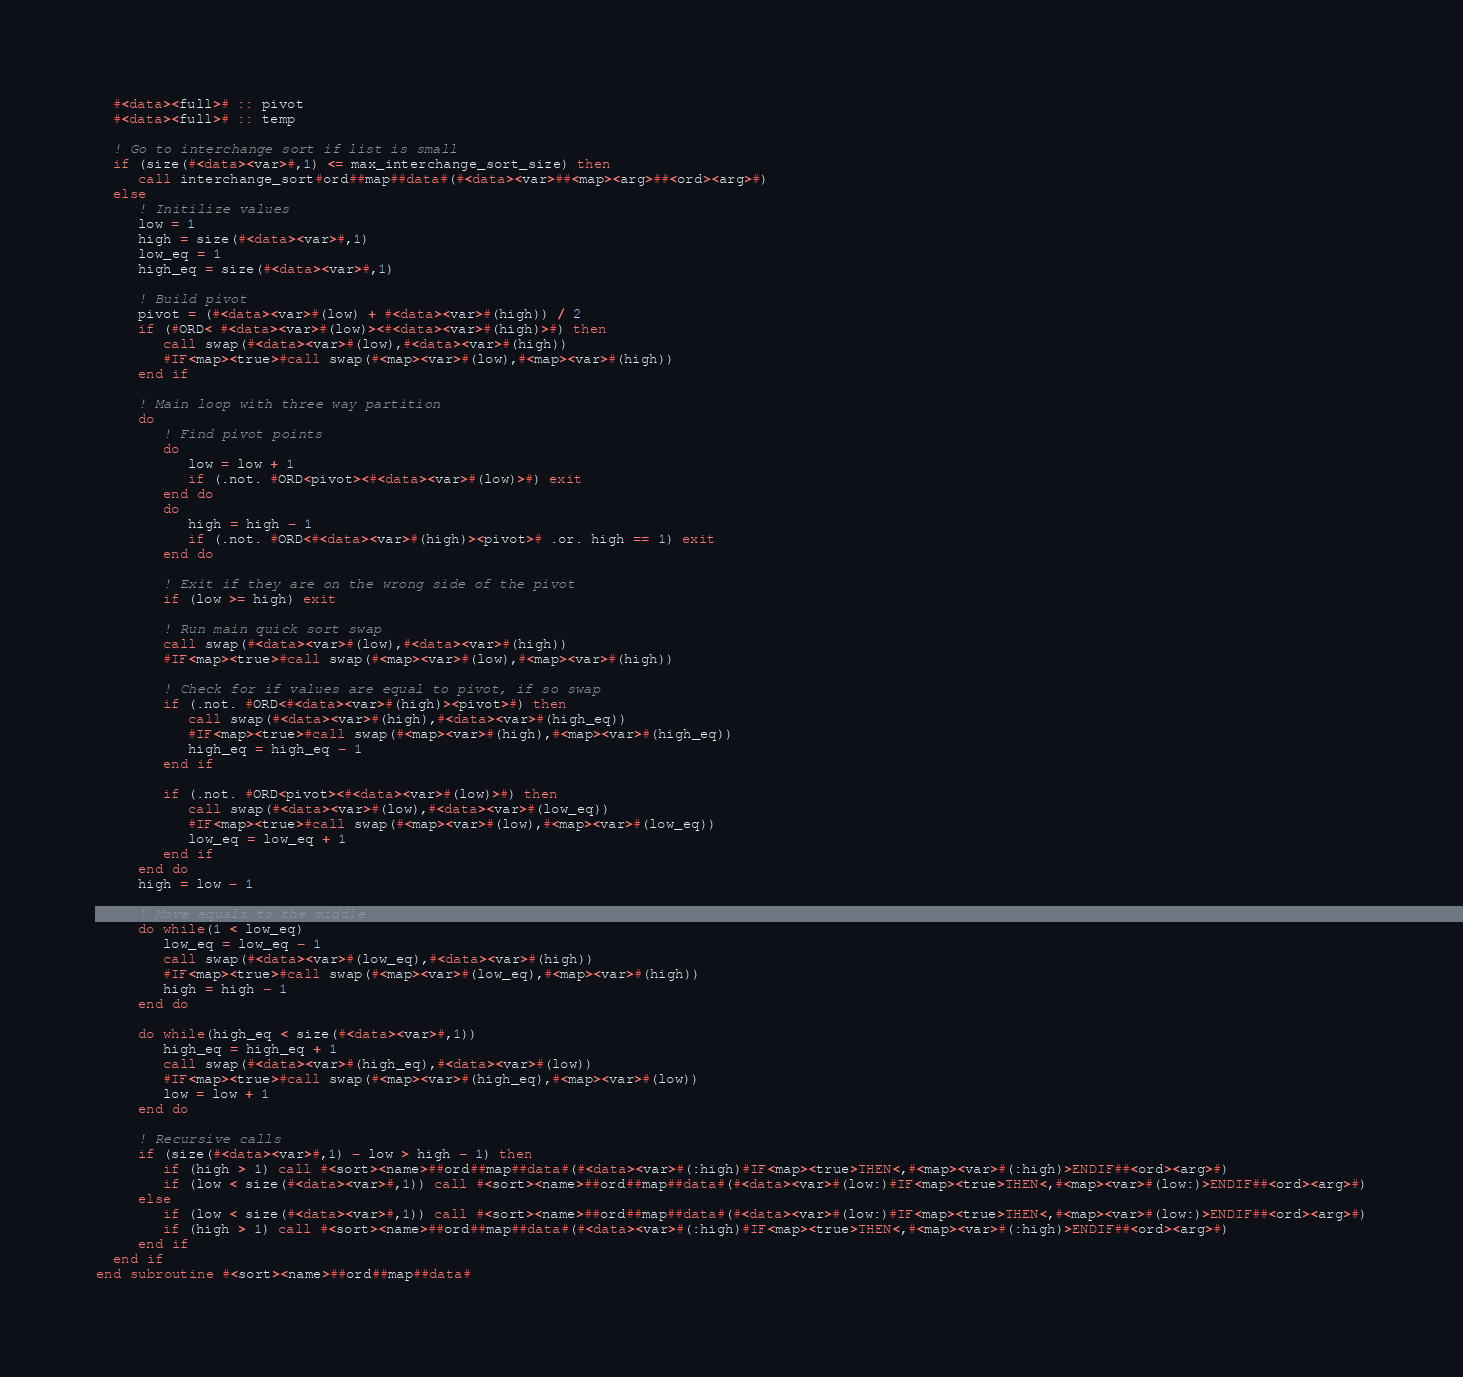Convert code to text. <code><loc_0><loc_0><loc_500><loc_500><_FORTRAN_>  #<data><full># :: pivot
  #<data><full># :: temp

  ! Go to interchange sort if list is small
  if (size(#<data><var>#,1) <= max_interchange_sort_size) then
     call interchange_sort#ord##map##data#(#<data><var>##<map><arg>##<ord><arg>#)
  else
     ! Initilize values
     low = 1
     high = size(#<data><var>#,1)
     low_eq = 1
     high_eq = size(#<data><var>#,1)

     ! Build pivot
     pivot = (#<data><var>#(low) + #<data><var>#(high)) / 2
     if (#ORD< #<data><var>#(low)><#<data><var>#(high)>#) then
        call swap(#<data><var>#(low),#<data><var>#(high))
        #IF<map><true>#call swap(#<map><var>#(low),#<map><var>#(high))
     end if
     
     ! Main loop with three way partition
     do 
        ! Find pivot points
        do
           low = low + 1
           if (.not. #ORD<pivot><#<data><var>#(low)>#) exit
        end do
        do 
           high = high - 1
           if (.not. #ORD<#<data><var>#(high)><pivot># .or. high == 1) exit
        end do

        ! Exit if they are on the wrong side of the pivot
        if (low >= high) exit

        ! Run main quick sort swap
        call swap(#<data><var>#(low),#<data><var>#(high))
        #IF<map><true>#call swap(#<map><var>#(low),#<map><var>#(high))

        ! Check for if values are equal to pivot, if so swap
        if (.not. #ORD<#<data><var>#(high)><pivot>#) then
           call swap(#<data><var>#(high),#<data><var>#(high_eq))
           #IF<map><true>#call swap(#<map><var>#(high),#<map><var>#(high_eq))
           high_eq = high_eq - 1
        end if

        if (.not. #ORD<pivot><#<data><var>#(low)>#) then
           call swap(#<data><var>#(low),#<data><var>#(low_eq))
           #IF<map><true>#call swap(#<map><var>#(low),#<map><var>#(low_eq))
           low_eq = low_eq + 1
        end if
     end do
     high = low - 1

     ! Move equals to the middle
     do while(1 < low_eq)
        low_eq = low_eq - 1
        call swap(#<data><var>#(low_eq),#<data><var>#(high))
        #IF<map><true>#call swap(#<map><var>#(low_eq),#<map><var>#(high))
        high = high - 1
     end do
     
     do while(high_eq < size(#<data><var>#,1))
        high_eq = high_eq + 1
        call swap(#<data><var>#(high_eq),#<data><var>#(low))
        #IF<map><true>#call swap(#<map><var>#(high_eq),#<map><var>#(low))
        low = low + 1
     end do
     
     ! Recursive calls 
     if (size(#<data><var>#,1) - low > high - 1) then
        if (high > 1) call #<sort><name>##ord##map##data#(#<data><var>#(:high)#IF<map><true>THEN<,#<map><var>#(:high)>ENDIF##<ord><arg>#)
        if (low < size(#<data><var>#,1)) call #<sort><name>##ord##map##data#(#<data><var>#(low:)#IF<map><true>THEN<,#<map><var>#(low:)>ENDIF##<ord><arg>#)
     else
        if (low < size(#<data><var>#,1)) call #<sort><name>##ord##map##data#(#<data><var>#(low:)#IF<map><true>THEN<,#<map><var>#(low:)>ENDIF##<ord><arg>#)
        if (high > 1) call #<sort><name>##ord##map##data#(#<data><var>#(:high)#IF<map><true>THEN<,#<map><var>#(:high)>ENDIF##<ord><arg>#)
     end if
  end if
end subroutine #<sort><name>##ord##map##data#

</code> 